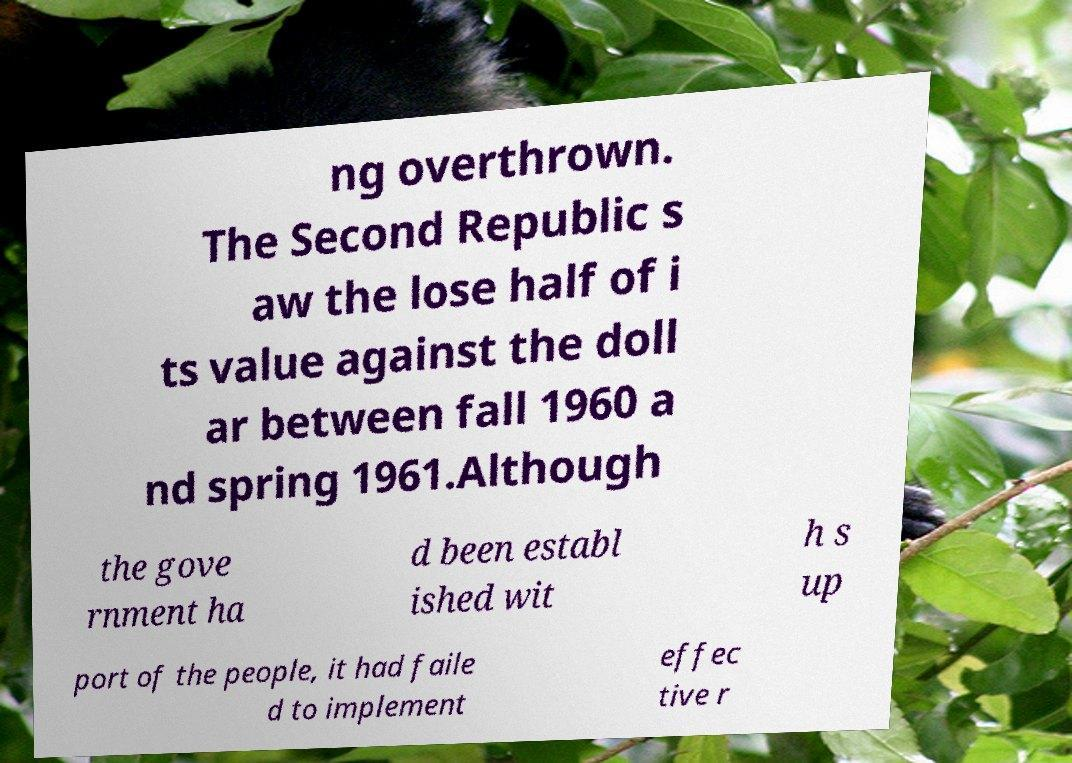Could you extract and type out the text from this image? ng overthrown. The Second Republic s aw the lose half of i ts value against the doll ar between fall 1960 a nd spring 1961.Although the gove rnment ha d been establ ished wit h s up port of the people, it had faile d to implement effec tive r 